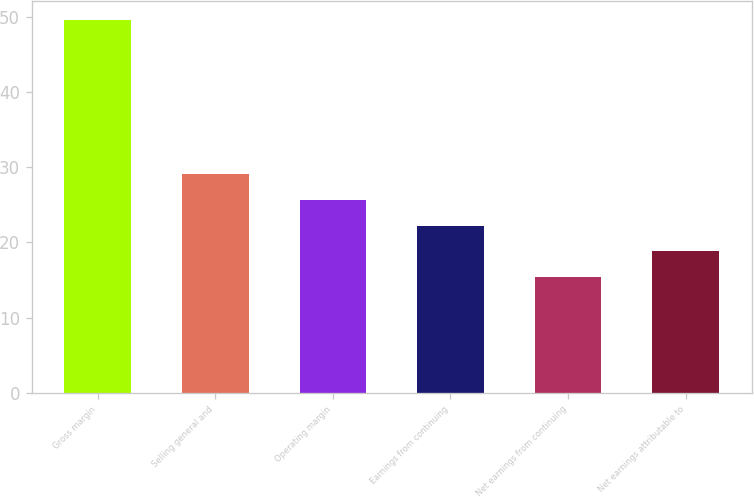Convert chart. <chart><loc_0><loc_0><loc_500><loc_500><bar_chart><fcel>Gross margin<fcel>Selling general and<fcel>Operating margin<fcel>Earnings from continuing<fcel>Net earnings from continuing<fcel>Net earnings attributable to<nl><fcel>49.6<fcel>29.08<fcel>25.66<fcel>22.24<fcel>15.4<fcel>18.82<nl></chart> 